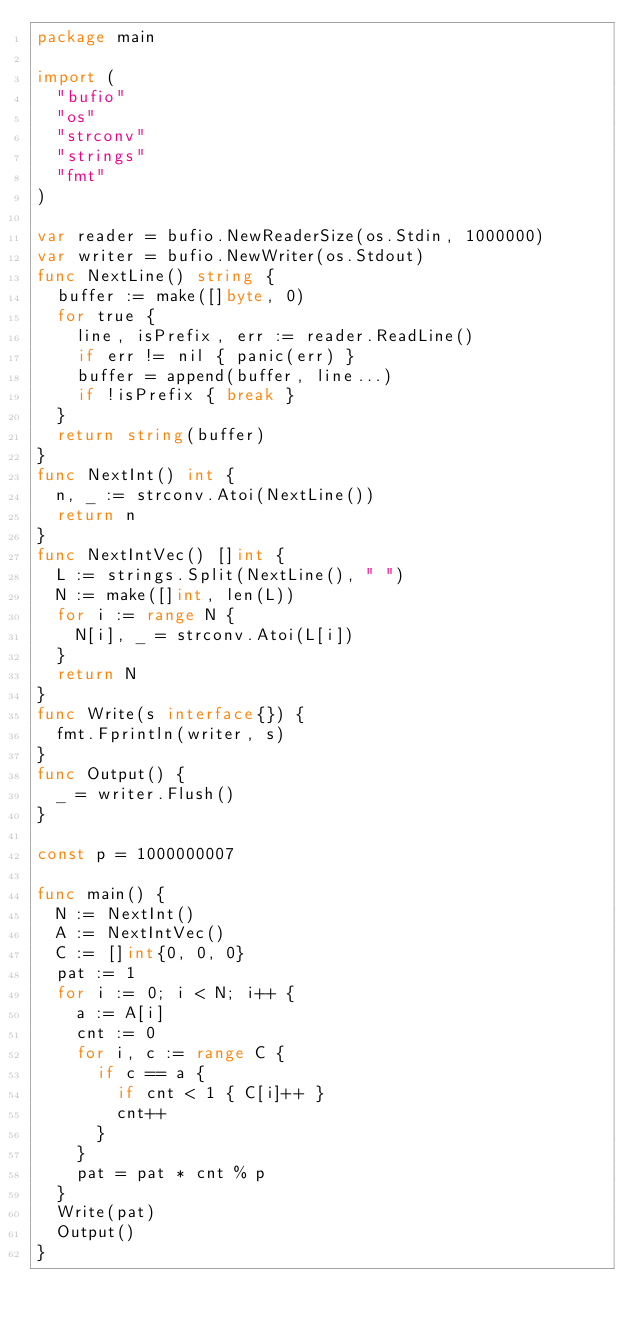<code> <loc_0><loc_0><loc_500><loc_500><_Go_>package main

import (
  "bufio"
  "os"
  "strconv"
  "strings"
  "fmt"
)

var reader = bufio.NewReaderSize(os.Stdin, 1000000)
var writer = bufio.NewWriter(os.Stdout)
func NextLine() string {
  buffer := make([]byte, 0)
  for true {
    line, isPrefix, err := reader.ReadLine()
    if err != nil { panic(err) }
    buffer = append(buffer, line...)
    if !isPrefix { break }
  }
  return string(buffer)
}
func NextInt() int {
  n, _ := strconv.Atoi(NextLine())
  return n
}
func NextIntVec() []int {
  L := strings.Split(NextLine(), " ")
  N := make([]int, len(L))
  for i := range N {
    N[i], _ = strconv.Atoi(L[i])
  }
  return N
}
func Write(s interface{}) {
  fmt.Fprintln(writer, s)
}
func Output() {
  _ = writer.Flush()
}

const p = 1000000007

func main() {
  N := NextInt()
  A := NextIntVec()
  C := []int{0, 0, 0}
  pat := 1
  for i := 0; i < N; i++ {
    a := A[i]
    cnt := 0
    for i, c := range C {
      if c == a {
        if cnt < 1 { C[i]++ }
        cnt++
      }
    }
    pat = pat * cnt % p
  }
  Write(pat)
  Output()
}</code> 